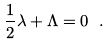Convert formula to latex. <formula><loc_0><loc_0><loc_500><loc_500>\frac { 1 } { 2 } \lambda + \Lambda = 0 \ .</formula> 